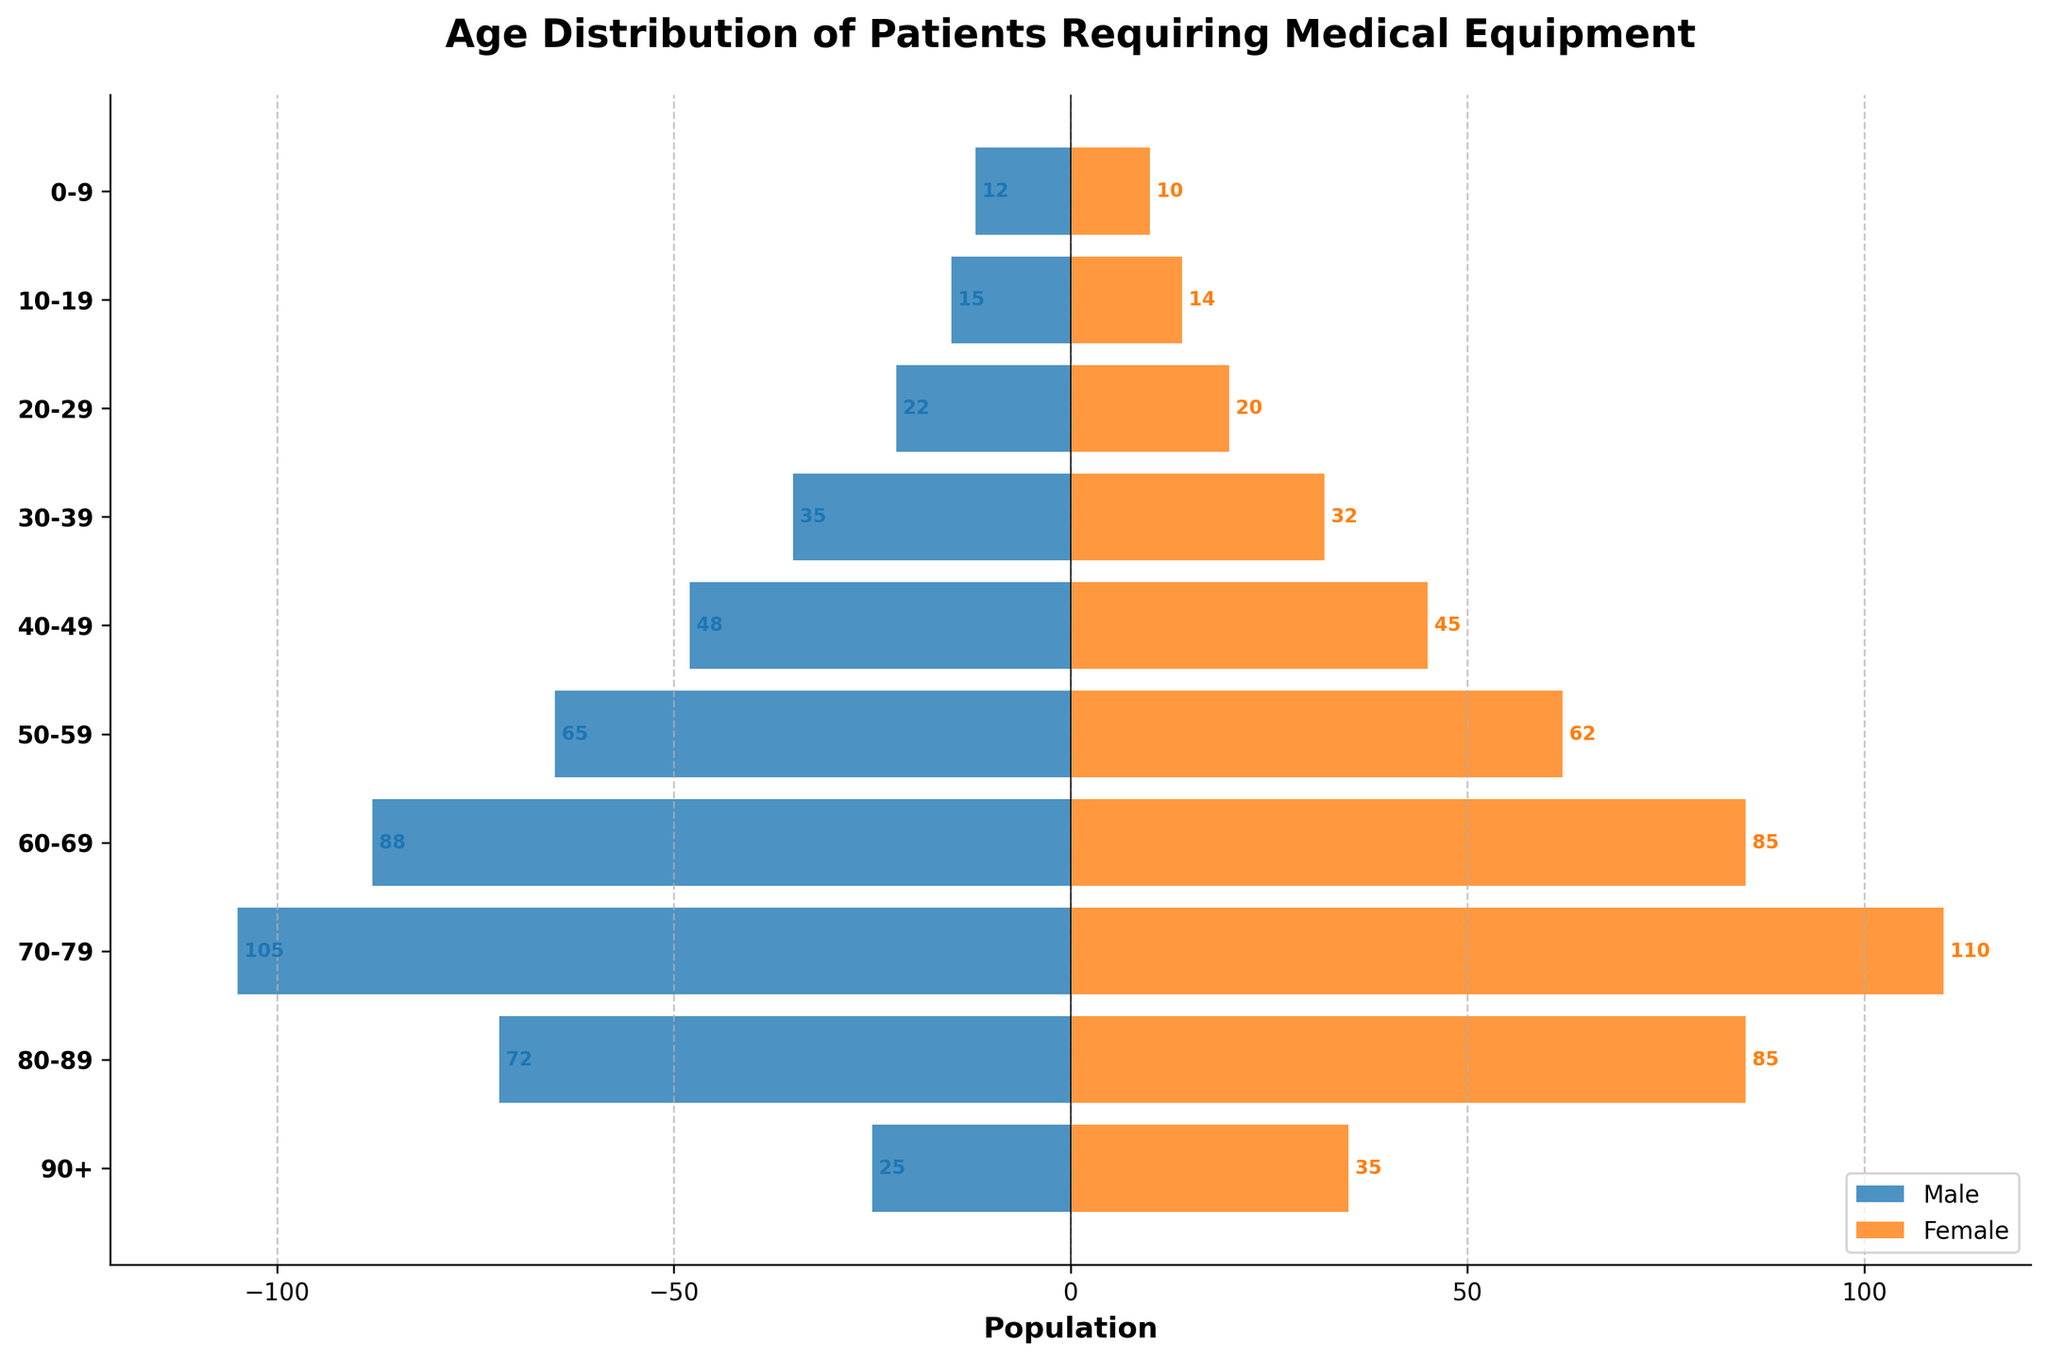What is the title of the figure? The title is located at the top of the figure, in bold and larger font. It reads "Age Distribution of Patients Requiring Medical Equipment".
Answer: Age Distribution of Patients Requiring Medical Equipment How many age groups are represented in the figure? The y-axis labels represent the age groups. By counting the number of labels, there are 10 age groups.
Answer: 10 Which age group has the highest number of male patients? The male bars are represented by blue bars protruding to the left. The longest blue bar corresponds to the age group 70-79.
Answer: 70-79 What is the difference in the number of female patients between the age groups 60-69 and 80-89? Female bars for the age groups 60-69 and 80-89 can be read directly from the plot. For 60-69, there are 85 females, and for 80-89, there are also 85 females, resulting in a difference of 0.
Answer: 0 In which age group do females outnumber males the most? By visually comparing the lengths of the orange (female) and blue (male) bars, the age group with the largest discrepancy appears to be 90+, where the female bar is significantly longer than the male bar.
Answer: 90+ Which age group shows the highest total number of patients? To find the total, the lengths of male and female bars are summed for each age group. The 70-79 age group has the highest combined lengths, indicating it has the highest total number of patients.
Answer: 70-79 How does the number of male patients in the 50-59 age group compare to the number of female patients in the same group? The number of patients in the 50-59 age group can be directly compared by looking at the lengths of the blue and orange bars. There are more males (65) than females (62), with a difference of 3.
Answer: Males > Females Which age group has the smallest difference between the number of males and females? To find the smallest difference, compare the lengths of the blue and orange bars for each age group. The age group 0-9 shows the closest values between males and females (12 males, 10 females) with a difference of 2.
Answer: 0-9 What are the overall trends in the age distribution of patients requiring medical equipment? Reviewing the pattern of bar lengths, it can be seen that the number of patients increases with age, peaking in the 70-79 age group, and then decreases. Males generally outnumber females in younger groups, but females outnumber males in older age groups.
Answer: Increase till 70-79, then decrease; Males > Females in younger, Females > Males in older 